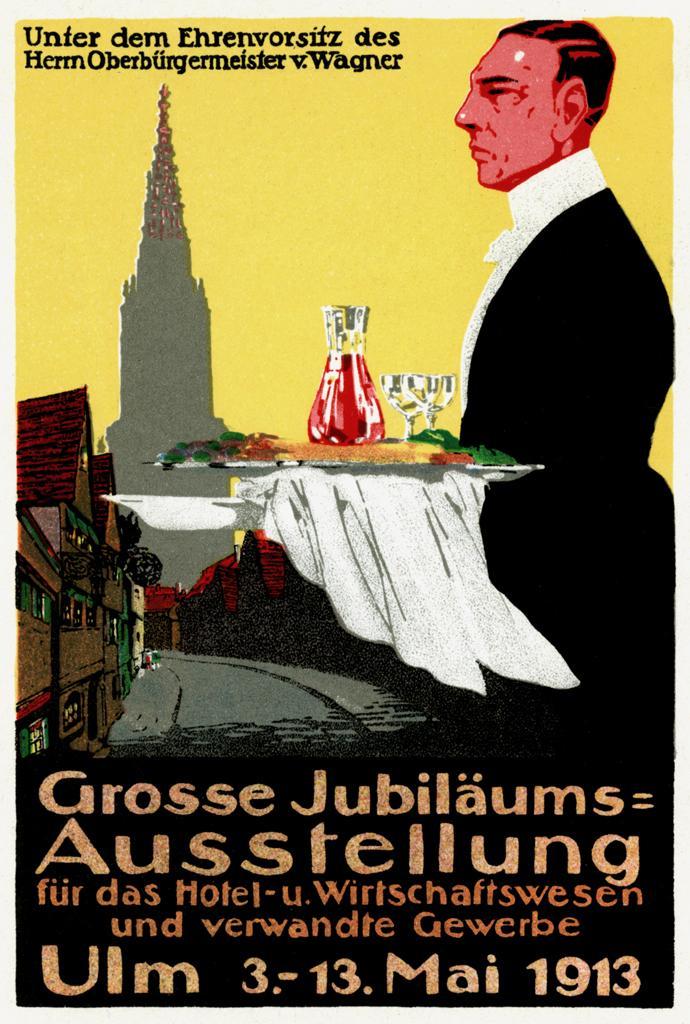Could you give a brief overview of what you see in this image? In this picture I can see the depiction image and I see a man who is wearing formal dress and I see that he is holding a thing on which there is a jar and 2 glasses and I see the white color cloth. I can also see number of buildings and the path and I see that there is something written on the bottom and top of this picture. 